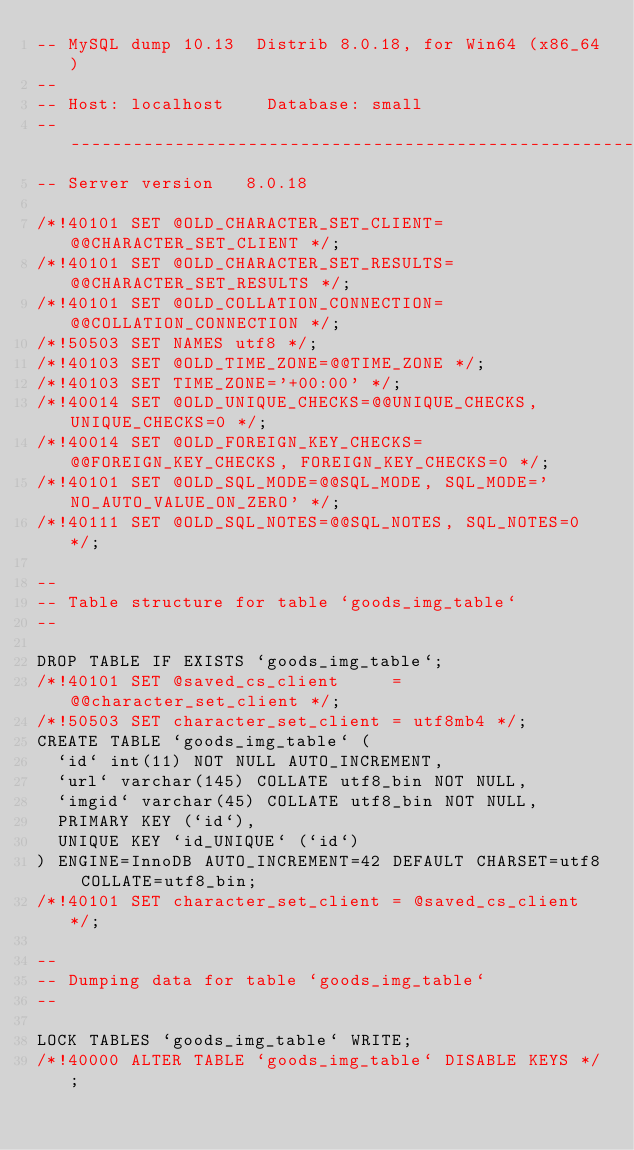Convert code to text. <code><loc_0><loc_0><loc_500><loc_500><_SQL_>-- MySQL dump 10.13  Distrib 8.0.18, for Win64 (x86_64)
--
-- Host: localhost    Database: small
-- ------------------------------------------------------
-- Server version	8.0.18

/*!40101 SET @OLD_CHARACTER_SET_CLIENT=@@CHARACTER_SET_CLIENT */;
/*!40101 SET @OLD_CHARACTER_SET_RESULTS=@@CHARACTER_SET_RESULTS */;
/*!40101 SET @OLD_COLLATION_CONNECTION=@@COLLATION_CONNECTION */;
/*!50503 SET NAMES utf8 */;
/*!40103 SET @OLD_TIME_ZONE=@@TIME_ZONE */;
/*!40103 SET TIME_ZONE='+00:00' */;
/*!40014 SET @OLD_UNIQUE_CHECKS=@@UNIQUE_CHECKS, UNIQUE_CHECKS=0 */;
/*!40014 SET @OLD_FOREIGN_KEY_CHECKS=@@FOREIGN_KEY_CHECKS, FOREIGN_KEY_CHECKS=0 */;
/*!40101 SET @OLD_SQL_MODE=@@SQL_MODE, SQL_MODE='NO_AUTO_VALUE_ON_ZERO' */;
/*!40111 SET @OLD_SQL_NOTES=@@SQL_NOTES, SQL_NOTES=0 */;

--
-- Table structure for table `goods_img_table`
--

DROP TABLE IF EXISTS `goods_img_table`;
/*!40101 SET @saved_cs_client     = @@character_set_client */;
/*!50503 SET character_set_client = utf8mb4 */;
CREATE TABLE `goods_img_table` (
  `id` int(11) NOT NULL AUTO_INCREMENT,
  `url` varchar(145) COLLATE utf8_bin NOT NULL,
  `imgid` varchar(45) COLLATE utf8_bin NOT NULL,
  PRIMARY KEY (`id`),
  UNIQUE KEY `id_UNIQUE` (`id`)
) ENGINE=InnoDB AUTO_INCREMENT=42 DEFAULT CHARSET=utf8 COLLATE=utf8_bin;
/*!40101 SET character_set_client = @saved_cs_client */;

--
-- Dumping data for table `goods_img_table`
--

LOCK TABLES `goods_img_table` WRITE;
/*!40000 ALTER TABLE `goods_img_table` DISABLE KEYS */;</code> 